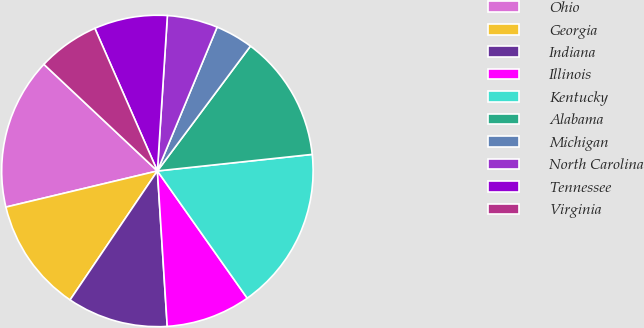Convert chart. <chart><loc_0><loc_0><loc_500><loc_500><pie_chart><fcel>Ohio<fcel>Georgia<fcel>Indiana<fcel>Illinois<fcel>Kentucky<fcel>Alabama<fcel>Michigan<fcel>North Carolina<fcel>Tennessee<fcel>Virginia<nl><fcel>15.73%<fcel>11.8%<fcel>10.48%<fcel>8.78%<fcel>16.91%<fcel>13.11%<fcel>3.93%<fcel>5.24%<fcel>7.6%<fcel>6.42%<nl></chart> 